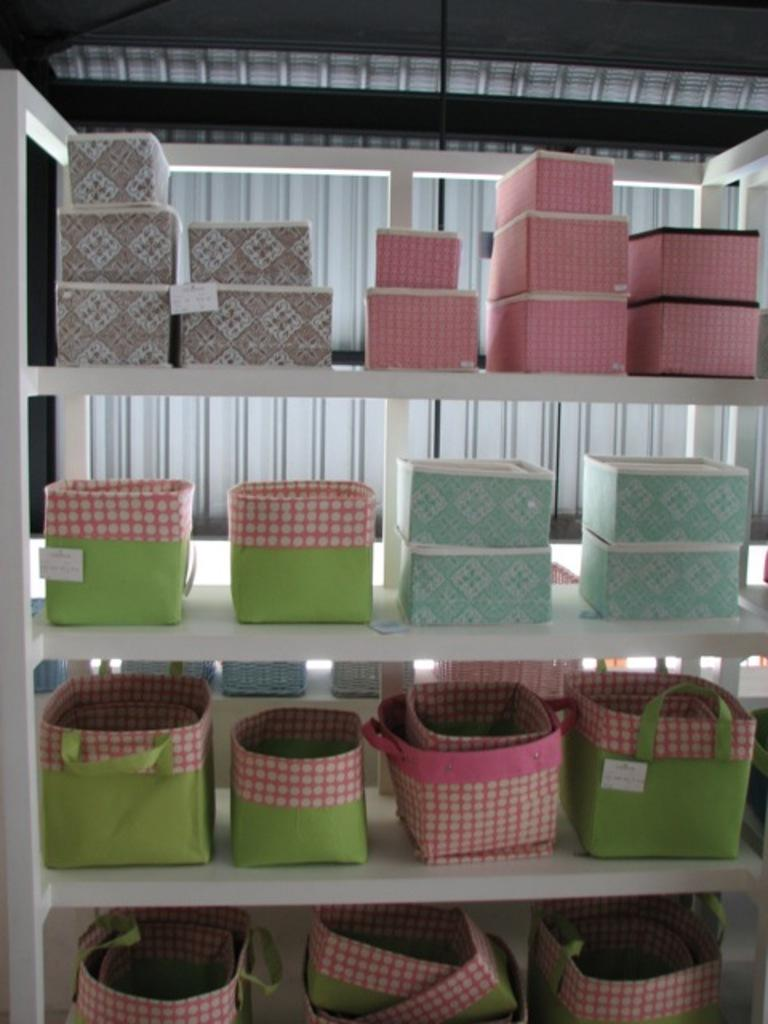What type of objects can be seen in the image? There are boxes and bags in the image. Where are the boxes and bags located? The boxes and bags are in racks. Can you tell me how many bears are sitting on the boxes in the image? There are no bears present in the image; it only features boxes and bags in racks. 